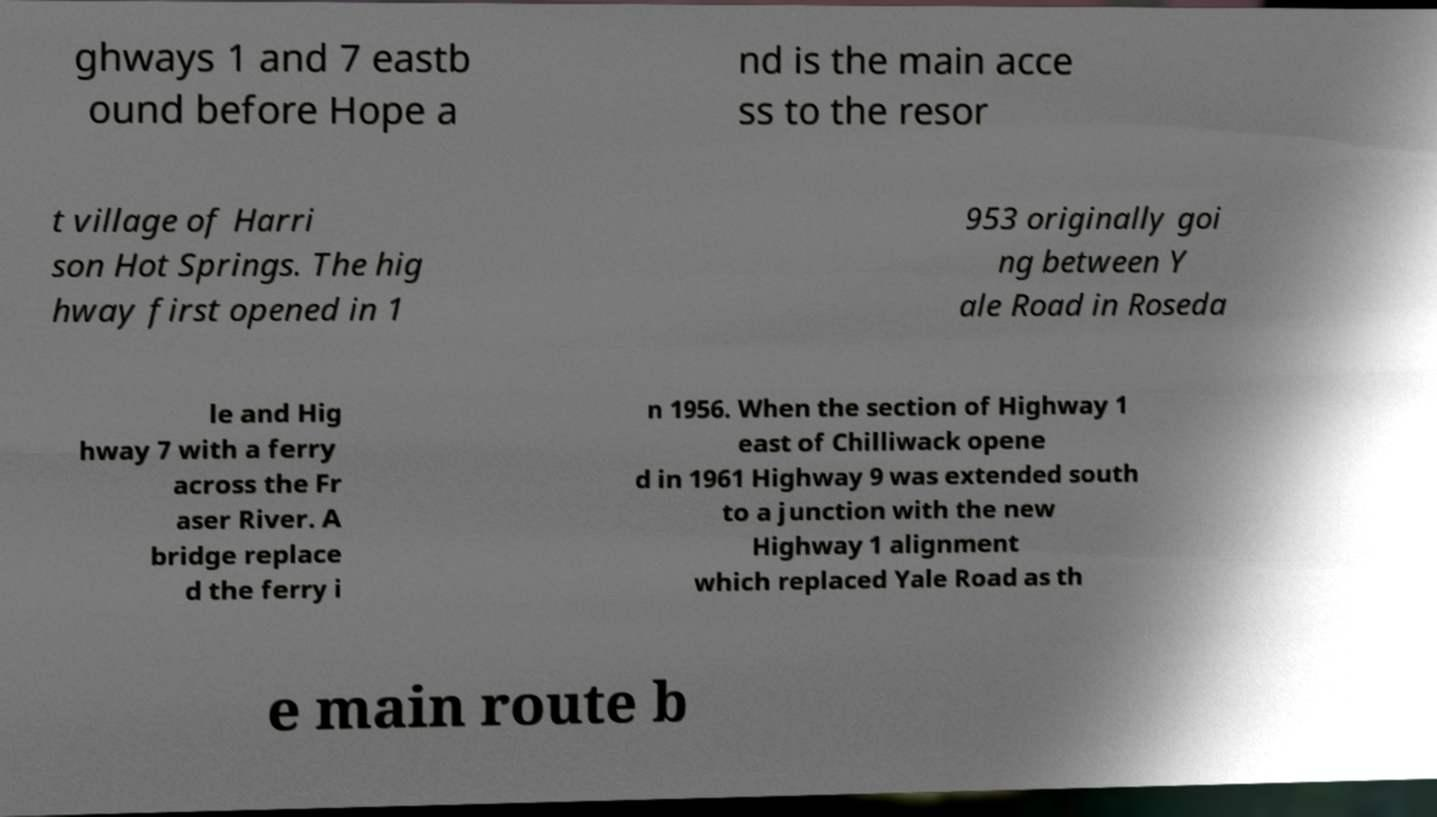Please identify and transcribe the text found in this image. ghways 1 and 7 eastb ound before Hope a nd is the main acce ss to the resor t village of Harri son Hot Springs. The hig hway first opened in 1 953 originally goi ng between Y ale Road in Roseda le and Hig hway 7 with a ferry across the Fr aser River. A bridge replace d the ferry i n 1956. When the section of Highway 1 east of Chilliwack opene d in 1961 Highway 9 was extended south to a junction with the new Highway 1 alignment which replaced Yale Road as th e main route b 